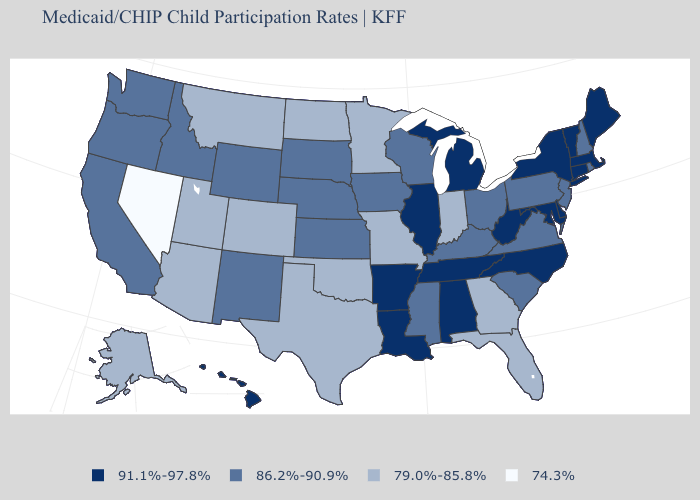What is the value of New York?
Quick response, please. 91.1%-97.8%. Name the states that have a value in the range 86.2%-90.9%?
Short answer required. California, Idaho, Iowa, Kansas, Kentucky, Mississippi, Nebraska, New Hampshire, New Jersey, New Mexico, Ohio, Oregon, Pennsylvania, Rhode Island, South Carolina, South Dakota, Virginia, Washington, Wisconsin, Wyoming. What is the highest value in the USA?
Concise answer only. 91.1%-97.8%. Name the states that have a value in the range 86.2%-90.9%?
Answer briefly. California, Idaho, Iowa, Kansas, Kentucky, Mississippi, Nebraska, New Hampshire, New Jersey, New Mexico, Ohio, Oregon, Pennsylvania, Rhode Island, South Carolina, South Dakota, Virginia, Washington, Wisconsin, Wyoming. Name the states that have a value in the range 79.0%-85.8%?
Be succinct. Alaska, Arizona, Colorado, Florida, Georgia, Indiana, Minnesota, Missouri, Montana, North Dakota, Oklahoma, Texas, Utah. Which states have the lowest value in the Northeast?
Write a very short answer. New Hampshire, New Jersey, Pennsylvania, Rhode Island. Name the states that have a value in the range 91.1%-97.8%?
Answer briefly. Alabama, Arkansas, Connecticut, Delaware, Hawaii, Illinois, Louisiana, Maine, Maryland, Massachusetts, Michigan, New York, North Carolina, Tennessee, Vermont, West Virginia. What is the highest value in the MidWest ?
Quick response, please. 91.1%-97.8%. Does Idaho have the lowest value in the USA?
Concise answer only. No. What is the value of South Carolina?
Short answer required. 86.2%-90.9%. Does Washington have a higher value than West Virginia?
Short answer required. No. What is the value of Vermont?
Answer briefly. 91.1%-97.8%. What is the highest value in the South ?
Quick response, please. 91.1%-97.8%. Does Rhode Island have a higher value than Florida?
Give a very brief answer. Yes. Among the states that border North Dakota , which have the lowest value?
Give a very brief answer. Minnesota, Montana. 